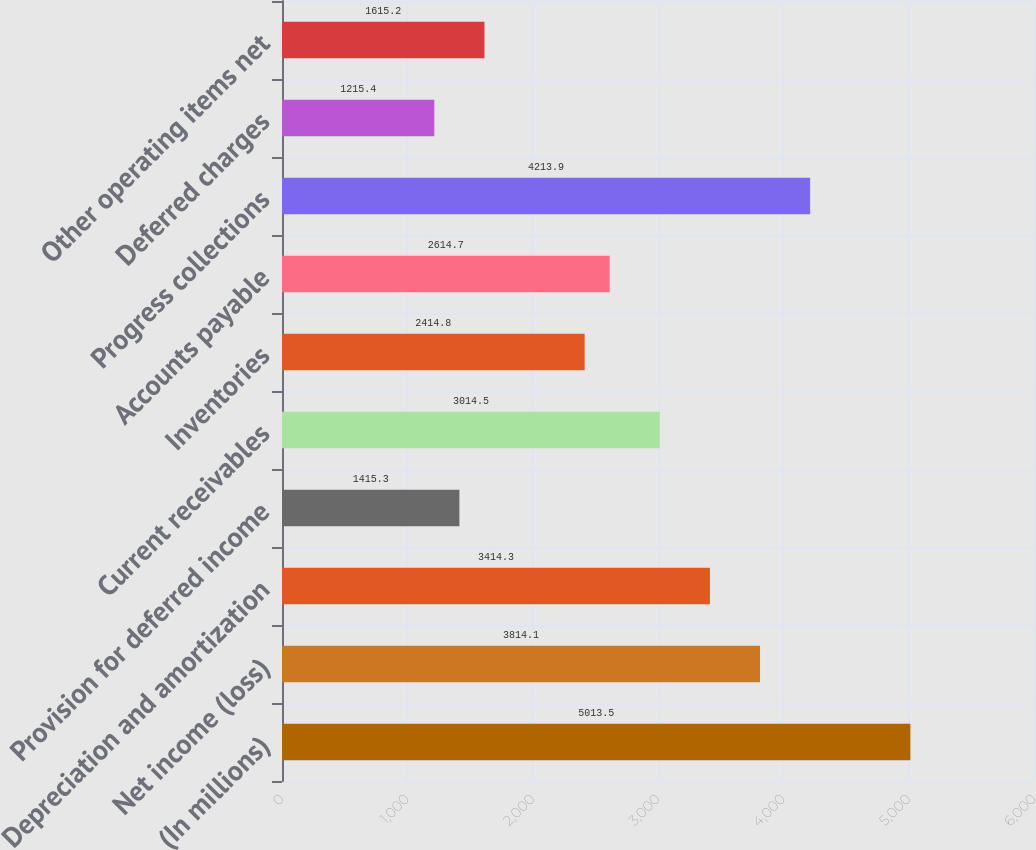Convert chart. <chart><loc_0><loc_0><loc_500><loc_500><bar_chart><fcel>(In millions)<fcel>Net income (loss)<fcel>Depreciation and amortization<fcel>Provision for deferred income<fcel>Current receivables<fcel>Inventories<fcel>Accounts payable<fcel>Progress collections<fcel>Deferred charges<fcel>Other operating items net<nl><fcel>5013.5<fcel>3814.1<fcel>3414.3<fcel>1415.3<fcel>3014.5<fcel>2414.8<fcel>2614.7<fcel>4213.9<fcel>1215.4<fcel>1615.2<nl></chart> 